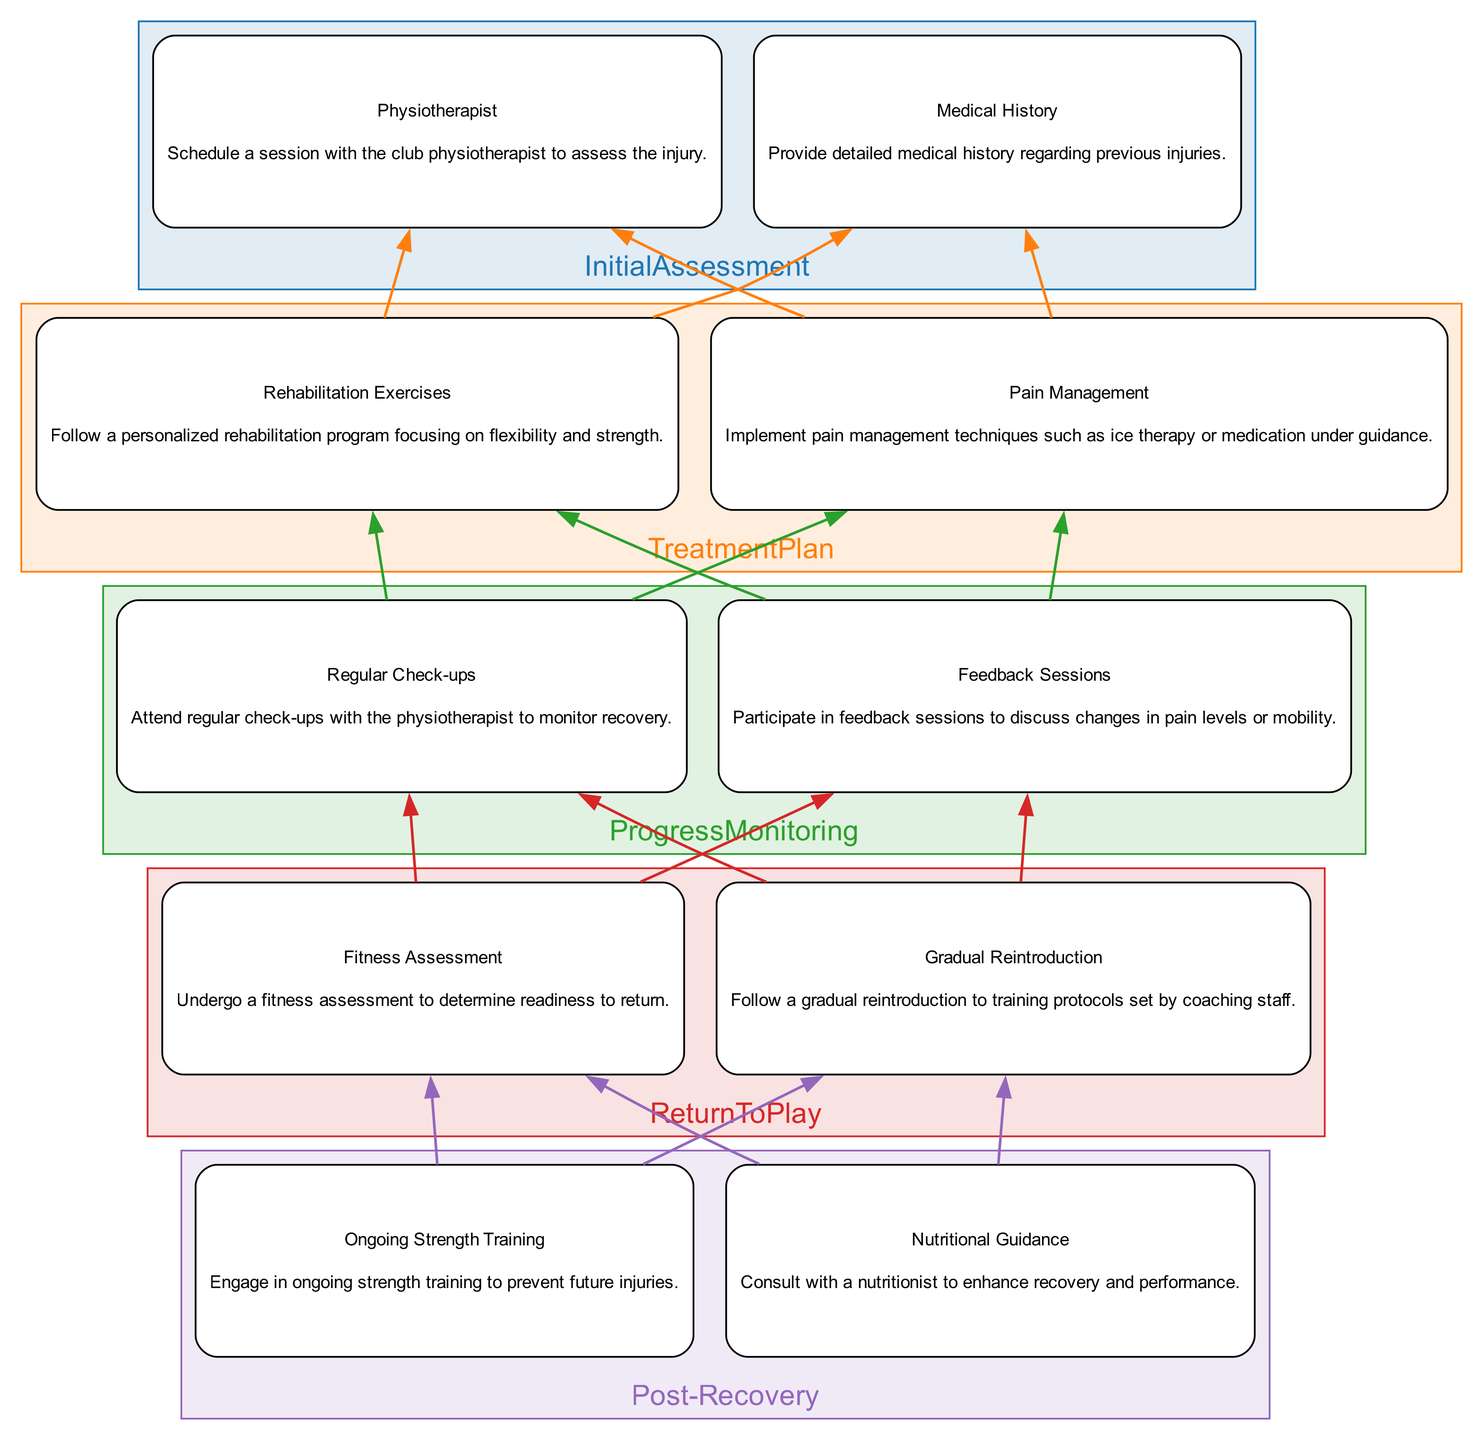What is the first step in the injury recovery process? The first step, as indicated in the diagram, is "Initial Assessment." This is the beginning phase where the athlete assesses the injury with the physiotherapist.
Answer: Initial Assessment How many main steps are there in the injury recovery process? By counting the main steps in the diagram, we see that there are five distinct steps: Initial Assessment, Treatment Plan, Progress Monitoring, Return to Play, and Post-Recovery.
Answer: Five What does the 'Treatment Plan' include? The 'Treatment Plan' includes two components: 'Rehabilitation Exercises' and 'Pain Management.' This indicates the techniques and exercises prescribed for recovery.
Answer: Rehabilitation Exercises and Pain Management What is involved in the 'Progress Monitoring' phase? In this phase, the athlete must attend 'Regular Check-ups' and participate in 'Feedback Sessions' according to the diagram. Both actions are crucial for gauging recovery progress.
Answer: Regular Check-ups and Feedback Sessions Which step follows 'Return to Play'? The step that follows 'Return to Play' in the diagram is 'Post-Recovery.' It highlights ongoing actions taken to ensure continued health and performance after the athlete returns to play.
Answer: Post-Recovery What is required before returning to play? Before returning to play, the athlete must undergo a 'Fitness Assessment' to confirm they are ready. This step is essential to avoid re-injury.
Answer: Fitness Assessment What must an athlete not skip during the recovery process to prevent future injuries? To prevent future injuries, the athlete should engage in 'Ongoing Strength Training' according to the post-recovery phase of the diagram. This indicates the importance of continuous conditioning.
Answer: Ongoing Strength Training Which role primarily conducts the 'Initial Assessment'? The 'Initial Assessment' is primarily conducted by the 'Physiotherapist,' who schedules the session to evaluate the injury. This shows the physiotherapist's critical role in the recovery process.
Answer: Physiotherapist What is the purpose of 'Feedback Sessions'? 'Feedback Sessions' are held to discuss changes in pain levels or mobility, allowing for adjustment of recovery strategies based on the athlete’s information.
Answer: Discuss changes in pain levels or mobility What technique is included in the 'Pain Management' component? One of the techniques included in the 'Pain Management' component is 'ice therapy,' which is recommended under guidance, indicating its role in alleviating pain.
Answer: Ice therapy 